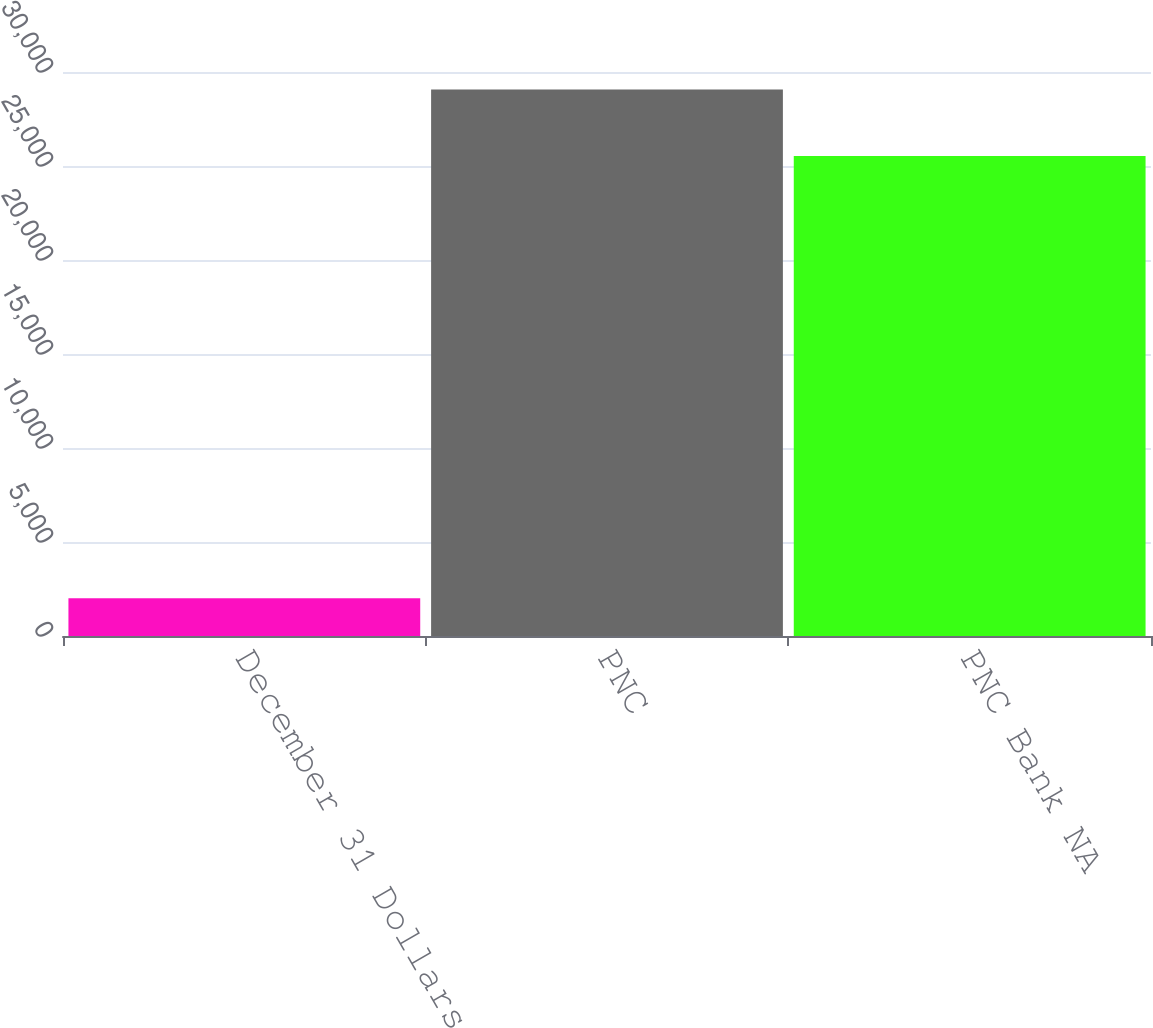Convert chart to OTSL. <chart><loc_0><loc_0><loc_500><loc_500><bar_chart><fcel>December 31 Dollars in<fcel>PNC<fcel>PNC Bank NA<nl><fcel>2011<fcel>29073<fcel>25536<nl></chart> 